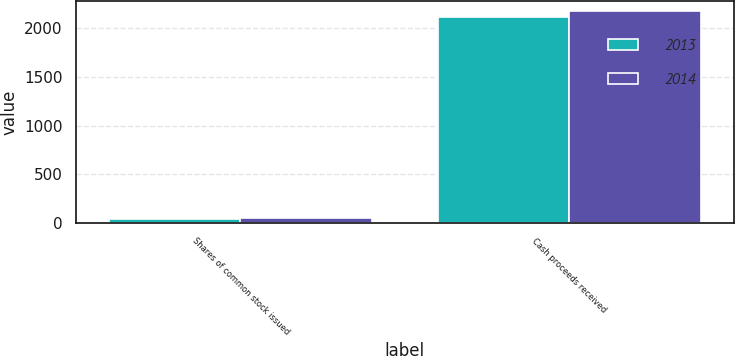Convert chart. <chart><loc_0><loc_0><loc_500><loc_500><stacked_bar_chart><ecel><fcel>Shares of common stock issued<fcel>Cash proceeds received<nl><fcel>2013<fcel>44<fcel>2119<nl><fcel>2014<fcel>53<fcel>2171<nl></chart> 